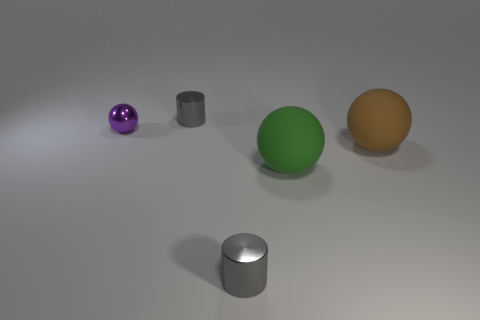Subtract all big green matte balls. How many balls are left? 2 Subtract all purple spheres. How many spheres are left? 2 Add 3 small spheres. How many objects exist? 8 Subtract all brown spheres. How many green cylinders are left? 0 Subtract all tiny spheres. Subtract all big brown rubber things. How many objects are left? 3 Add 3 purple spheres. How many purple spheres are left? 4 Add 5 purple metal spheres. How many purple metal spheres exist? 6 Subtract 0 brown blocks. How many objects are left? 5 Subtract all spheres. How many objects are left? 2 Subtract 2 cylinders. How many cylinders are left? 0 